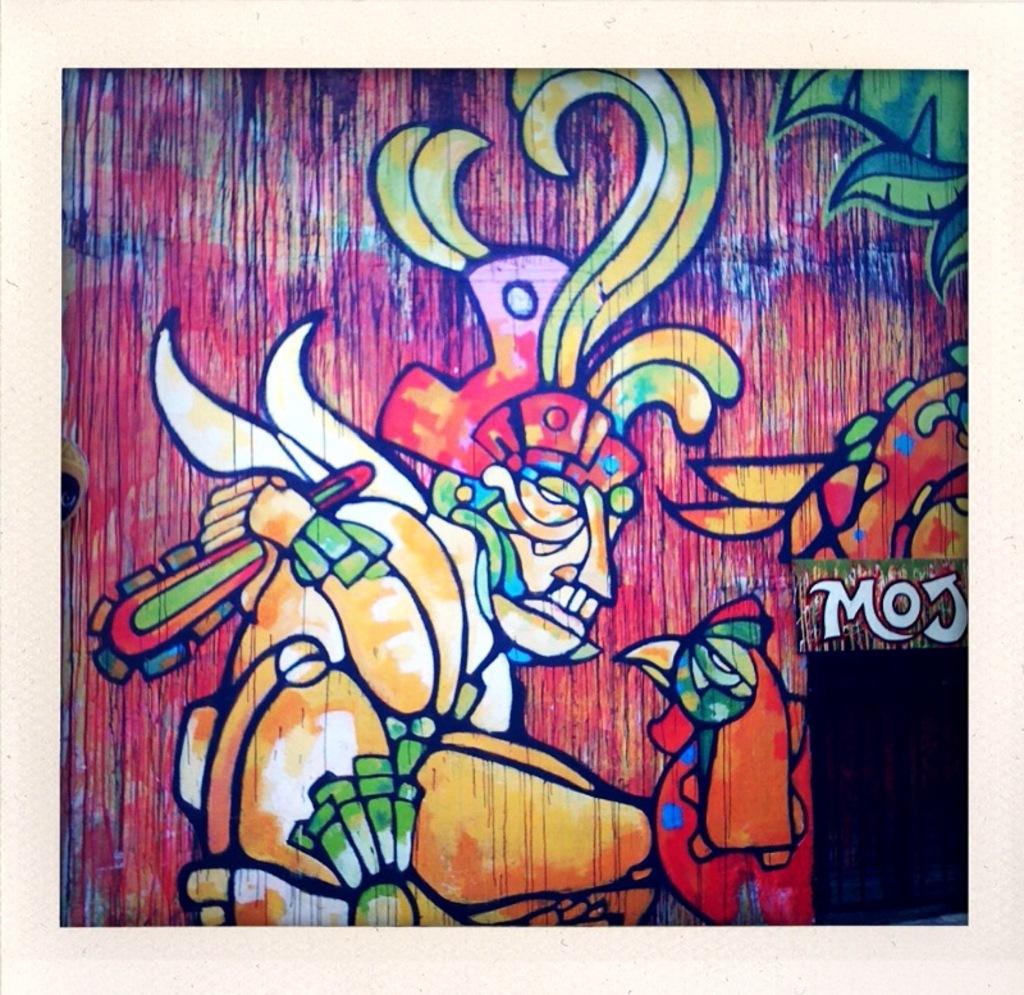What is the name of the graffiti artist?
Offer a terse response. Moj. 